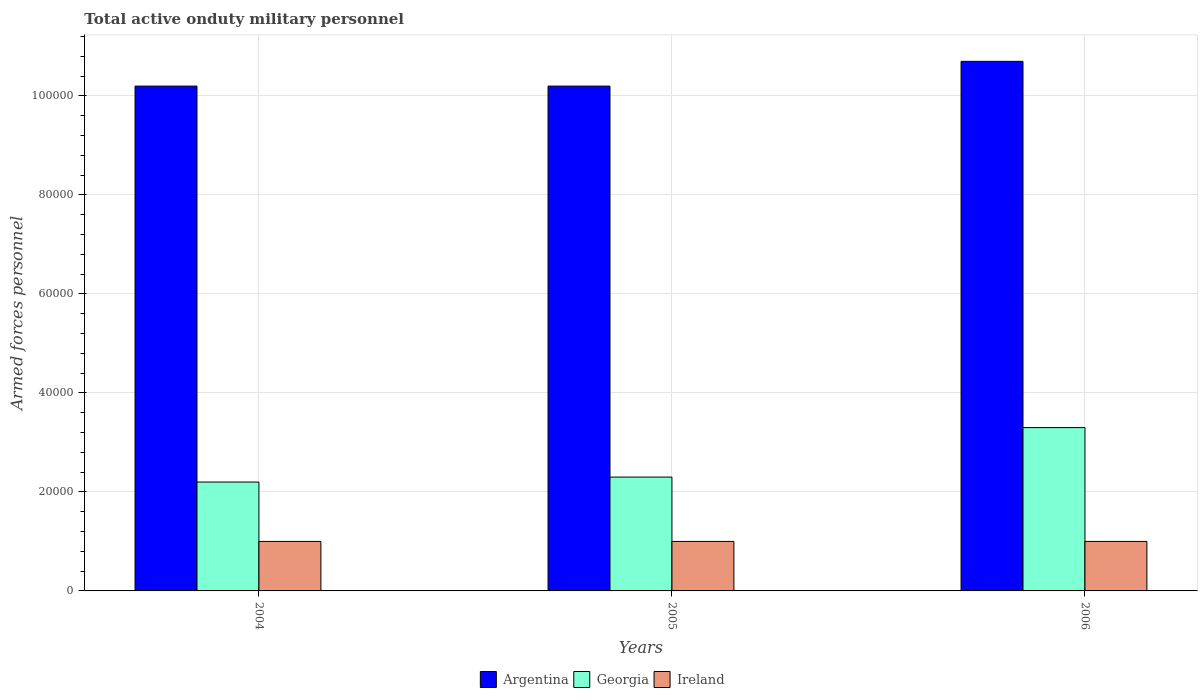Are the number of bars on each tick of the X-axis equal?
Your answer should be very brief. Yes. How many bars are there on the 1st tick from the right?
Your response must be concise. 3. In how many cases, is the number of bars for a given year not equal to the number of legend labels?
Your answer should be compact. 0. What is the number of armed forces personnel in Georgia in 2005?
Make the answer very short. 2.30e+04. Across all years, what is the maximum number of armed forces personnel in Ireland?
Your response must be concise. 10000. Across all years, what is the minimum number of armed forces personnel in Ireland?
Offer a very short reply. 10000. In which year was the number of armed forces personnel in Argentina minimum?
Your response must be concise. 2004. What is the total number of armed forces personnel in Georgia in the graph?
Offer a very short reply. 7.80e+04. What is the difference between the number of armed forces personnel in Argentina in 2005 and that in 2006?
Give a very brief answer. -5000. What is the difference between the number of armed forces personnel in Argentina in 2006 and the number of armed forces personnel in Ireland in 2004?
Provide a succinct answer. 9.70e+04. What is the average number of armed forces personnel in Georgia per year?
Provide a short and direct response. 2.60e+04. In the year 2005, what is the difference between the number of armed forces personnel in Georgia and number of armed forces personnel in Ireland?
Provide a succinct answer. 1.30e+04. In how many years, is the number of armed forces personnel in Ireland greater than 76000?
Ensure brevity in your answer.  0. What is the ratio of the number of armed forces personnel in Argentina in 2004 to that in 2005?
Provide a short and direct response. 1. Is the difference between the number of armed forces personnel in Georgia in 2005 and 2006 greater than the difference between the number of armed forces personnel in Ireland in 2005 and 2006?
Your answer should be compact. No. What is the difference between the highest and the second highest number of armed forces personnel in Georgia?
Ensure brevity in your answer.  10000. What is the difference between the highest and the lowest number of armed forces personnel in Georgia?
Offer a very short reply. 1.10e+04. In how many years, is the number of armed forces personnel in Georgia greater than the average number of armed forces personnel in Georgia taken over all years?
Make the answer very short. 1. Is the sum of the number of armed forces personnel in Argentina in 2004 and 2005 greater than the maximum number of armed forces personnel in Ireland across all years?
Your response must be concise. Yes. What does the 3rd bar from the left in 2005 represents?
Make the answer very short. Ireland. What does the 2nd bar from the right in 2005 represents?
Ensure brevity in your answer.  Georgia. Are all the bars in the graph horizontal?
Your response must be concise. No. How many years are there in the graph?
Provide a short and direct response. 3. Are the values on the major ticks of Y-axis written in scientific E-notation?
Keep it short and to the point. No. What is the title of the graph?
Provide a succinct answer. Total active onduty military personnel. What is the label or title of the X-axis?
Make the answer very short. Years. What is the label or title of the Y-axis?
Your answer should be very brief. Armed forces personnel. What is the Armed forces personnel of Argentina in 2004?
Provide a short and direct response. 1.02e+05. What is the Armed forces personnel of Georgia in 2004?
Your answer should be very brief. 2.20e+04. What is the Armed forces personnel in Ireland in 2004?
Provide a succinct answer. 10000. What is the Armed forces personnel in Argentina in 2005?
Make the answer very short. 1.02e+05. What is the Armed forces personnel in Georgia in 2005?
Offer a terse response. 2.30e+04. What is the Armed forces personnel in Argentina in 2006?
Offer a very short reply. 1.07e+05. What is the Armed forces personnel of Georgia in 2006?
Give a very brief answer. 3.30e+04. What is the Armed forces personnel in Ireland in 2006?
Keep it short and to the point. 10000. Across all years, what is the maximum Armed forces personnel of Argentina?
Ensure brevity in your answer.  1.07e+05. Across all years, what is the maximum Armed forces personnel of Georgia?
Keep it short and to the point. 3.30e+04. Across all years, what is the minimum Armed forces personnel of Argentina?
Provide a succinct answer. 1.02e+05. Across all years, what is the minimum Armed forces personnel in Georgia?
Your response must be concise. 2.20e+04. What is the total Armed forces personnel of Argentina in the graph?
Offer a very short reply. 3.11e+05. What is the total Armed forces personnel in Georgia in the graph?
Provide a succinct answer. 7.80e+04. What is the total Armed forces personnel in Ireland in the graph?
Provide a short and direct response. 3.00e+04. What is the difference between the Armed forces personnel of Argentina in 2004 and that in 2005?
Provide a succinct answer. 0. What is the difference between the Armed forces personnel in Georgia in 2004 and that in 2005?
Give a very brief answer. -1000. What is the difference between the Armed forces personnel of Argentina in 2004 and that in 2006?
Offer a terse response. -5000. What is the difference between the Armed forces personnel in Georgia in 2004 and that in 2006?
Offer a terse response. -1.10e+04. What is the difference between the Armed forces personnel in Ireland in 2004 and that in 2006?
Provide a short and direct response. 0. What is the difference between the Armed forces personnel of Argentina in 2005 and that in 2006?
Provide a short and direct response. -5000. What is the difference between the Armed forces personnel of Georgia in 2005 and that in 2006?
Your response must be concise. -10000. What is the difference between the Armed forces personnel of Ireland in 2005 and that in 2006?
Your response must be concise. 0. What is the difference between the Armed forces personnel of Argentina in 2004 and the Armed forces personnel of Georgia in 2005?
Your response must be concise. 7.90e+04. What is the difference between the Armed forces personnel in Argentina in 2004 and the Armed forces personnel in Ireland in 2005?
Provide a short and direct response. 9.20e+04. What is the difference between the Armed forces personnel of Georgia in 2004 and the Armed forces personnel of Ireland in 2005?
Provide a succinct answer. 1.20e+04. What is the difference between the Armed forces personnel of Argentina in 2004 and the Armed forces personnel of Georgia in 2006?
Provide a succinct answer. 6.90e+04. What is the difference between the Armed forces personnel of Argentina in 2004 and the Armed forces personnel of Ireland in 2006?
Make the answer very short. 9.20e+04. What is the difference between the Armed forces personnel of Georgia in 2004 and the Armed forces personnel of Ireland in 2006?
Ensure brevity in your answer.  1.20e+04. What is the difference between the Armed forces personnel of Argentina in 2005 and the Armed forces personnel of Georgia in 2006?
Your response must be concise. 6.90e+04. What is the difference between the Armed forces personnel in Argentina in 2005 and the Armed forces personnel in Ireland in 2006?
Ensure brevity in your answer.  9.20e+04. What is the difference between the Armed forces personnel of Georgia in 2005 and the Armed forces personnel of Ireland in 2006?
Your answer should be compact. 1.30e+04. What is the average Armed forces personnel in Argentina per year?
Make the answer very short. 1.04e+05. What is the average Armed forces personnel of Georgia per year?
Offer a very short reply. 2.60e+04. In the year 2004, what is the difference between the Armed forces personnel of Argentina and Armed forces personnel of Ireland?
Your answer should be very brief. 9.20e+04. In the year 2004, what is the difference between the Armed forces personnel in Georgia and Armed forces personnel in Ireland?
Your response must be concise. 1.20e+04. In the year 2005, what is the difference between the Armed forces personnel in Argentina and Armed forces personnel in Georgia?
Your response must be concise. 7.90e+04. In the year 2005, what is the difference between the Armed forces personnel of Argentina and Armed forces personnel of Ireland?
Your answer should be very brief. 9.20e+04. In the year 2005, what is the difference between the Armed forces personnel of Georgia and Armed forces personnel of Ireland?
Give a very brief answer. 1.30e+04. In the year 2006, what is the difference between the Armed forces personnel in Argentina and Armed forces personnel in Georgia?
Your answer should be very brief. 7.40e+04. In the year 2006, what is the difference between the Armed forces personnel in Argentina and Armed forces personnel in Ireland?
Your response must be concise. 9.70e+04. In the year 2006, what is the difference between the Armed forces personnel of Georgia and Armed forces personnel of Ireland?
Ensure brevity in your answer.  2.30e+04. What is the ratio of the Armed forces personnel of Georgia in 2004 to that in 2005?
Your answer should be compact. 0.96. What is the ratio of the Armed forces personnel of Argentina in 2004 to that in 2006?
Provide a succinct answer. 0.95. What is the ratio of the Armed forces personnel of Georgia in 2004 to that in 2006?
Give a very brief answer. 0.67. What is the ratio of the Armed forces personnel in Argentina in 2005 to that in 2006?
Make the answer very short. 0.95. What is the ratio of the Armed forces personnel in Georgia in 2005 to that in 2006?
Offer a very short reply. 0.7. What is the difference between the highest and the second highest Armed forces personnel of Argentina?
Your answer should be very brief. 5000. What is the difference between the highest and the second highest Armed forces personnel of Georgia?
Make the answer very short. 10000. What is the difference between the highest and the lowest Armed forces personnel of Argentina?
Offer a very short reply. 5000. What is the difference between the highest and the lowest Armed forces personnel in Georgia?
Your answer should be compact. 1.10e+04. 